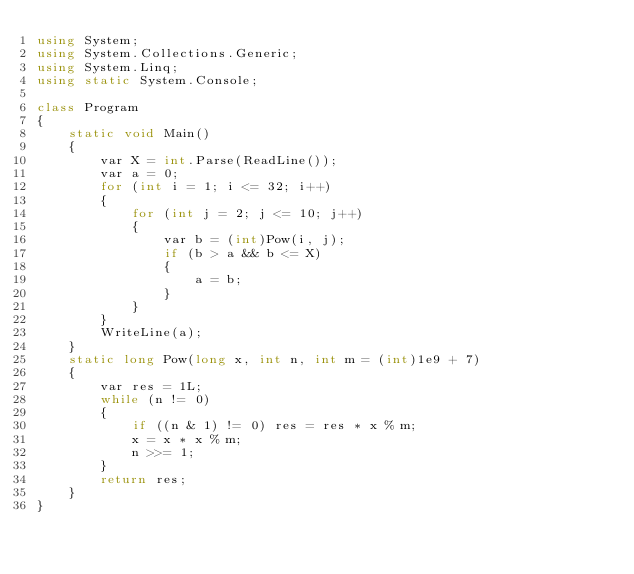<code> <loc_0><loc_0><loc_500><loc_500><_C#_>using System;
using System.Collections.Generic;
using System.Linq;
using static System.Console;

class Program
{
    static void Main()
    {
        var X = int.Parse(ReadLine());
        var a = 0;
        for (int i = 1; i <= 32; i++)
        {
            for (int j = 2; j <= 10; j++)
            {
                var b = (int)Pow(i, j);
                if (b > a && b <= X)
                {
                    a = b;
                }
            }
        }
        WriteLine(a);
    }
    static long Pow(long x, int n, int m = (int)1e9 + 7)
    {
        var res = 1L;
        while (n != 0)
        {
            if ((n & 1) != 0) res = res * x % m;
            x = x * x % m;
            n >>= 1;
        }
        return res;
    }
}</code> 